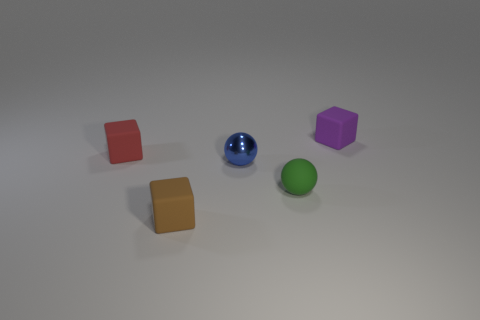There is a matte object that is to the left of the tiny cube in front of the small matte cube left of the tiny brown object; how big is it?
Make the answer very short. Small. How many green objects are either small matte objects or matte blocks?
Keep it short and to the point. 1. There is a tiny thing behind the red rubber object; does it have the same shape as the small red rubber object?
Your answer should be very brief. Yes. Is the number of tiny purple rubber blocks that are in front of the red matte cube greater than the number of small purple rubber blocks?
Provide a succinct answer. No. How many red balls have the same size as the purple cube?
Your answer should be compact. 0. What number of objects are either big brown metallic blocks or small rubber blocks to the left of the small brown matte thing?
Offer a very short reply. 1. There is a tiny object that is to the left of the blue sphere and in front of the small red object; what color is it?
Your response must be concise. Brown. Does the purple matte block have the same size as the green rubber ball?
Keep it short and to the point. Yes. The small sphere behind the tiny green thing is what color?
Your answer should be compact. Blue. Are there any other small spheres that have the same color as the metal ball?
Offer a terse response. No. 